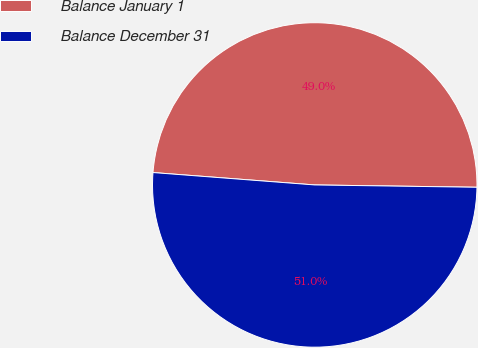Convert chart to OTSL. <chart><loc_0><loc_0><loc_500><loc_500><pie_chart><fcel>Balance January 1<fcel>Balance December 31<nl><fcel>49.01%<fcel>50.99%<nl></chart> 